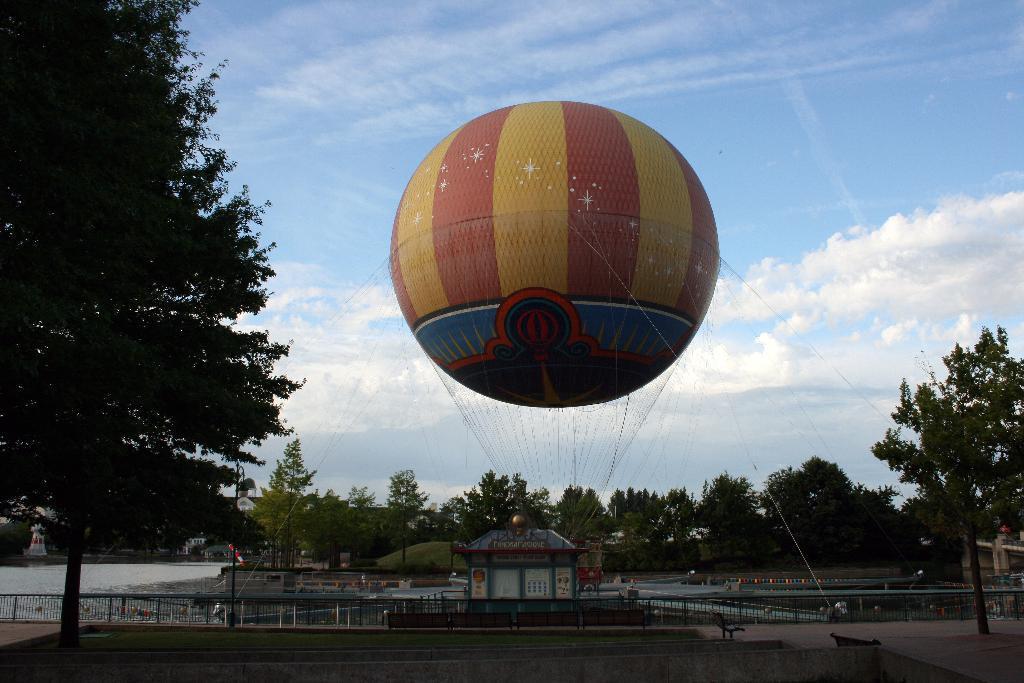Could you give a brief overview of what you see in this image? In this image there is a giant helium balloon with the threads , building, benches, plants, trees, water, iron grills,sky. 